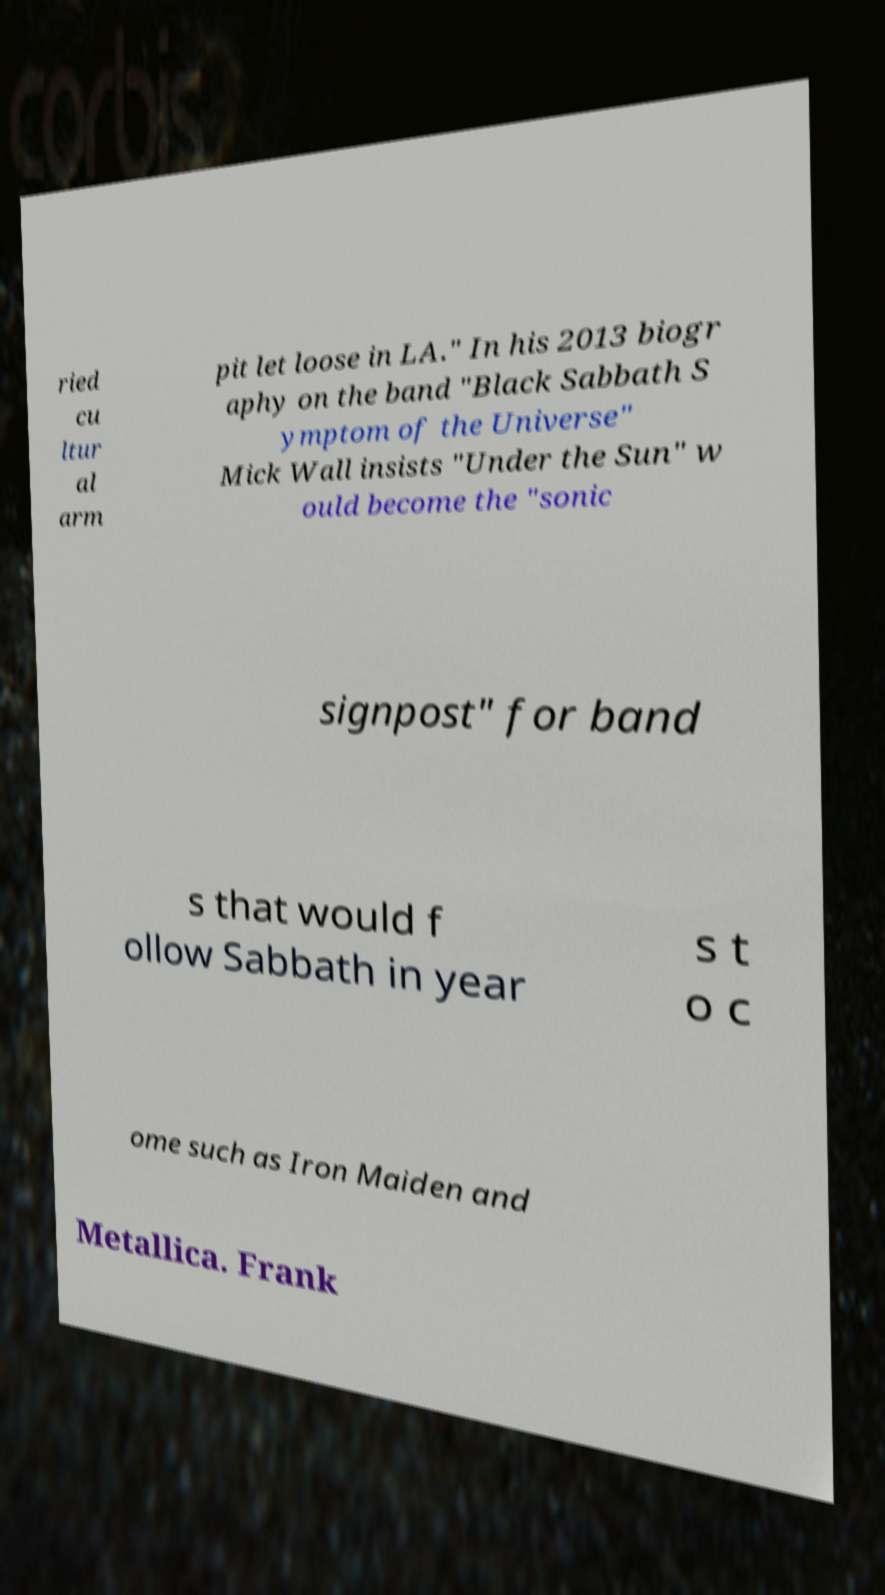Could you extract and type out the text from this image? ried cu ltur al arm pit let loose in LA." In his 2013 biogr aphy on the band "Black Sabbath S ymptom of the Universe" Mick Wall insists "Under the Sun" w ould become the "sonic signpost" for band s that would f ollow Sabbath in year s t o c ome such as Iron Maiden and Metallica. Frank 